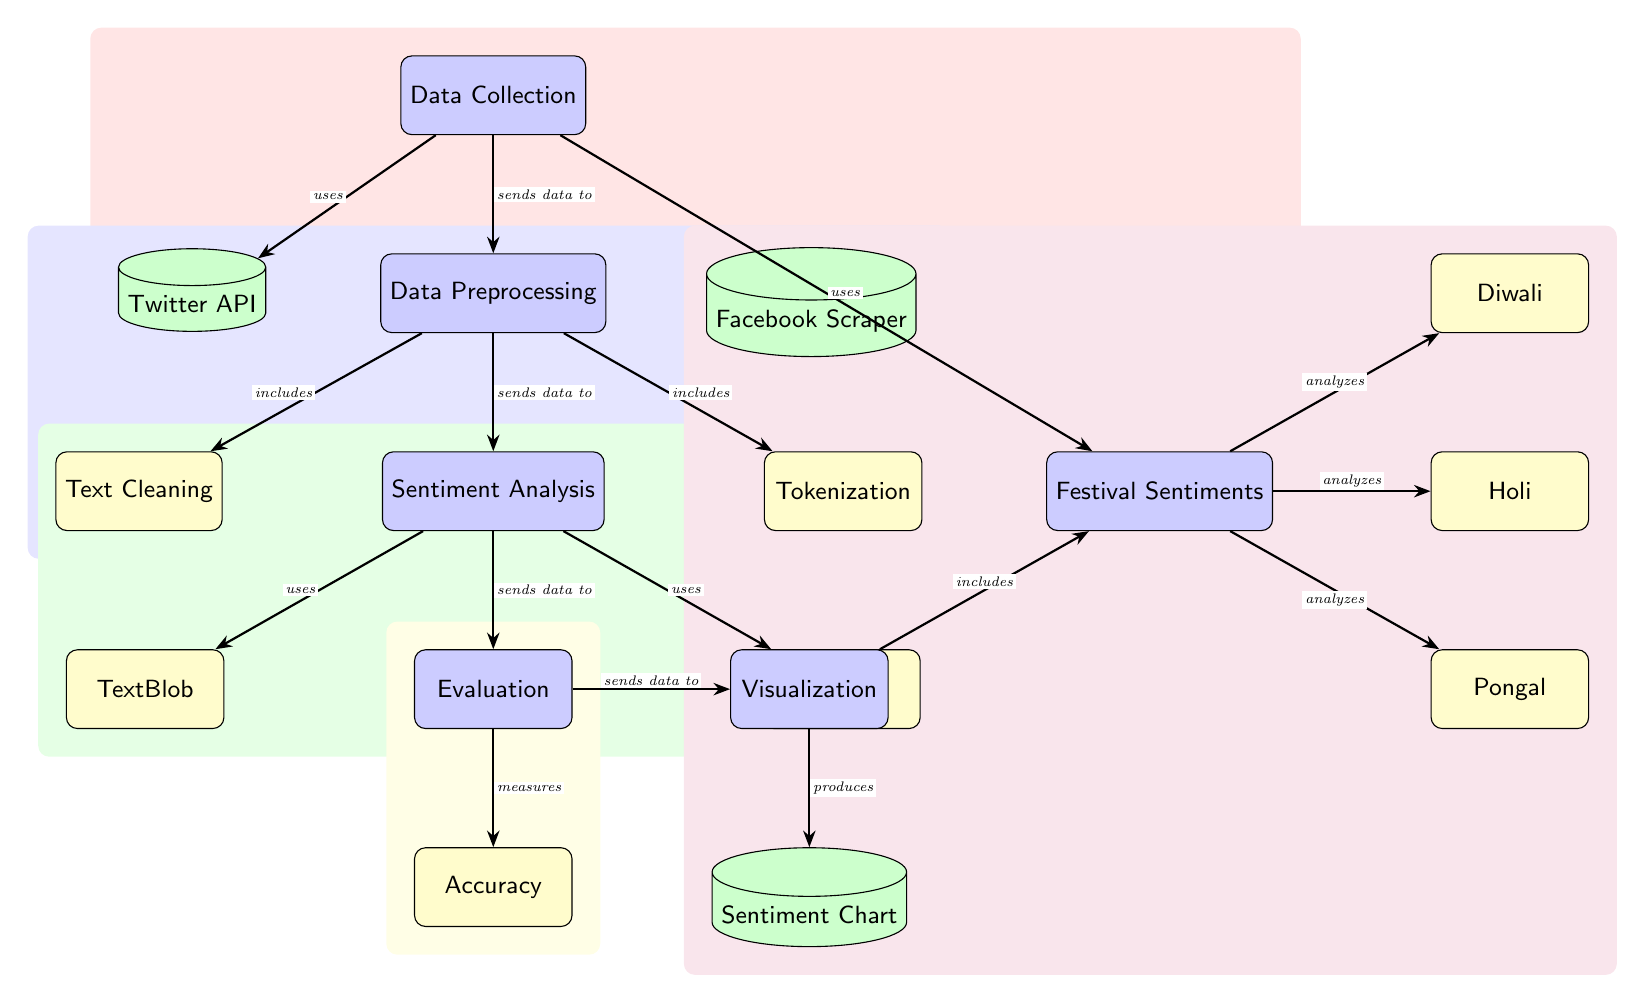What is the first process in the diagram? The diagram starts with the "Data Collection" process as indicated at the top.
Answer: Data Collection How many types of data sources are used for data collection? The diagram shows two sources: "Twitter API" and "Facebook Scraper."
Answer: Two What follows the data preprocessing step? After "Data Preprocessing," the next step is "Sentiment Analysis," which is connected with an arrow showing the flow.
Answer: Sentiment Analysis What tools are used for sentiment analysis? The two tools indicated in the diagram for sentiment analysis are "TextBlob" and "VADER."
Answer: TextBlob, VADER What is the final output of the visualization process? The final output produced by the visualization process is a "Sentiment Chart," which is clearly marked below.
Answer: Sentiment Chart Which festival is included in the analysis of the festival sentiments? The festival "Diwali" is included as one of the analyzed sentiments, as shown in the diagram.
Answer: Diwali How does sentiment analysis connect to the evaluation process? The sentiment analysis sends data to the evaluation process, indicating the flow of information from one process to the next.
Answer: Sends data to What is evaluated to assess the sentiment analysis? The evaluation process measures "Accuracy," as shown in the box directly related to it.
Answer: Accuracy Which process analyzes "Holi" sentiments? The process of "Festival Sentiments" includes analyzing "Holi," as it is connected by an arrow in the diagram.
Answer: Analyzes 